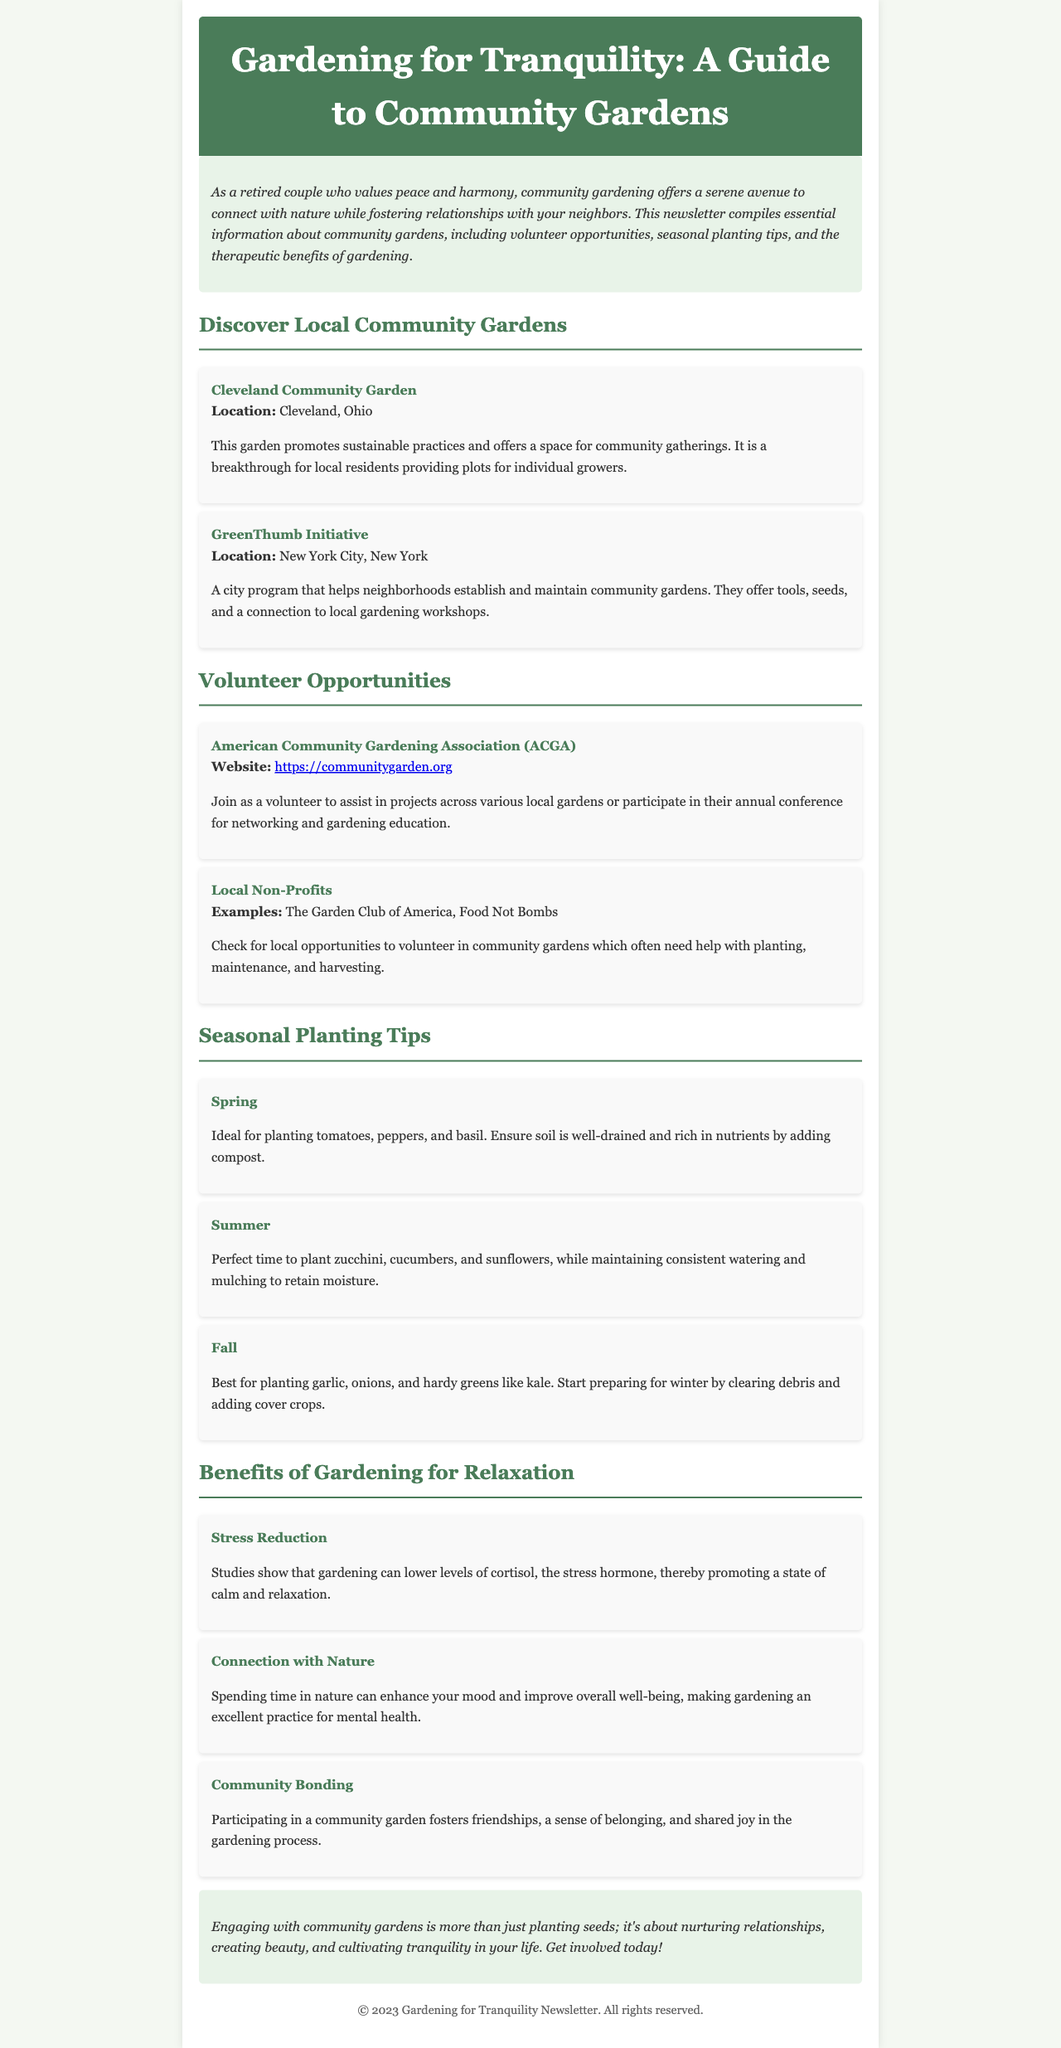What is the title of the newsletter? The title is clearly stated in the header of the document.
Answer: Gardening for Tranquility: A Guide to Community Gardens Where is the Cleveland Community Garden located? The location of the Cleveland Community Garden is mentioned in the description list.
Answer: Cleveland, Ohio What organization offers volunteer opportunities in community gardens? The document lists volunteer opportunities and the names of organizations that provide them.
Answer: American Community Gardening Association (ACGA) Which season is ideal for planting tomatoes, peppers, and basil? The seasonal planting tips section specifies the best times for planting different vegetables.
Answer: Spring What benefit of gardening is associated with lowering cortisol levels? The benefits section describes how gardening affects stress levels.
Answer: Stress Reduction What two plants are recommended for planting in summer? The seasonal planting tips section lists specific plants for the summer season.
Answer: Zucchini, cucumbers What is one way that community gardens foster social connections? The document discusses the social aspect of community gardening in the benefits section.
Answer: Community Bonding How many community gardens are mentioned in the document? By counting the specific gardens listed in the document, we can determine this number.
Answer: Two What color theme dominates the introductory section of the newsletter? The description of the introductory section provides insight into its design.
Answer: Green 